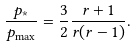Convert formula to latex. <formula><loc_0><loc_0><loc_500><loc_500>\frac { p _ { * } } { p _ { \max } } = \frac { 3 } { 2 } \frac { r + 1 } { r ( r - 1 ) } .</formula> 